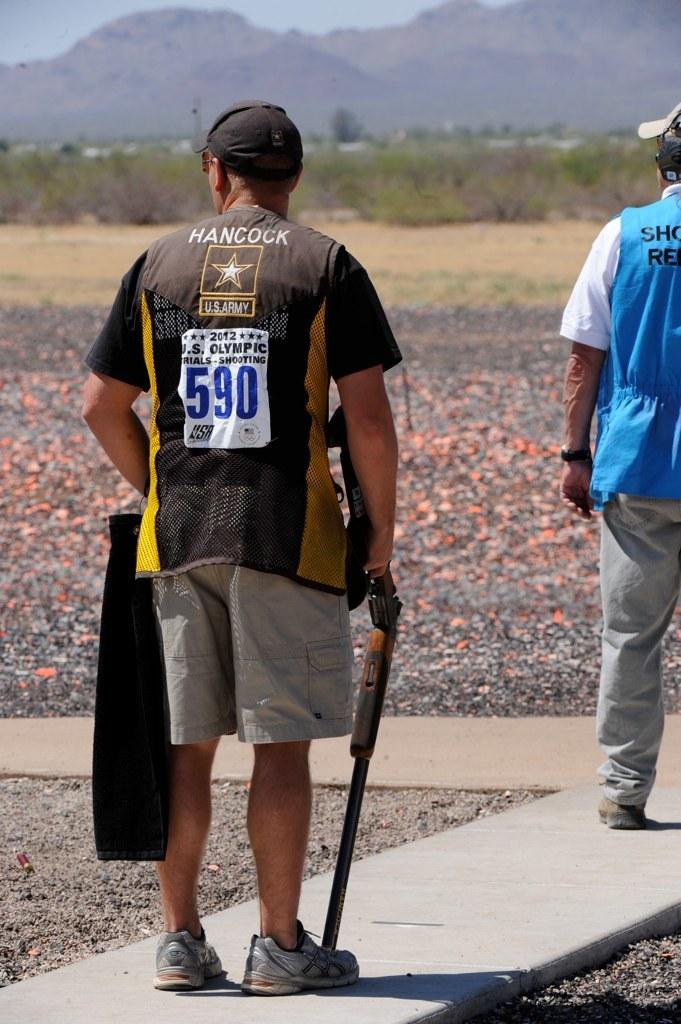<image>
Offer a succinct explanation of the picture presented. A man with the number 590 on the back of his shirt is holding a rifle. 